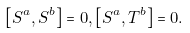Convert formula to latex. <formula><loc_0><loc_0><loc_500><loc_500>\left [ S ^ { a } , S ^ { b } \right ] = 0 , \left [ S ^ { a } , T ^ { b } \right ] = 0 .</formula> 